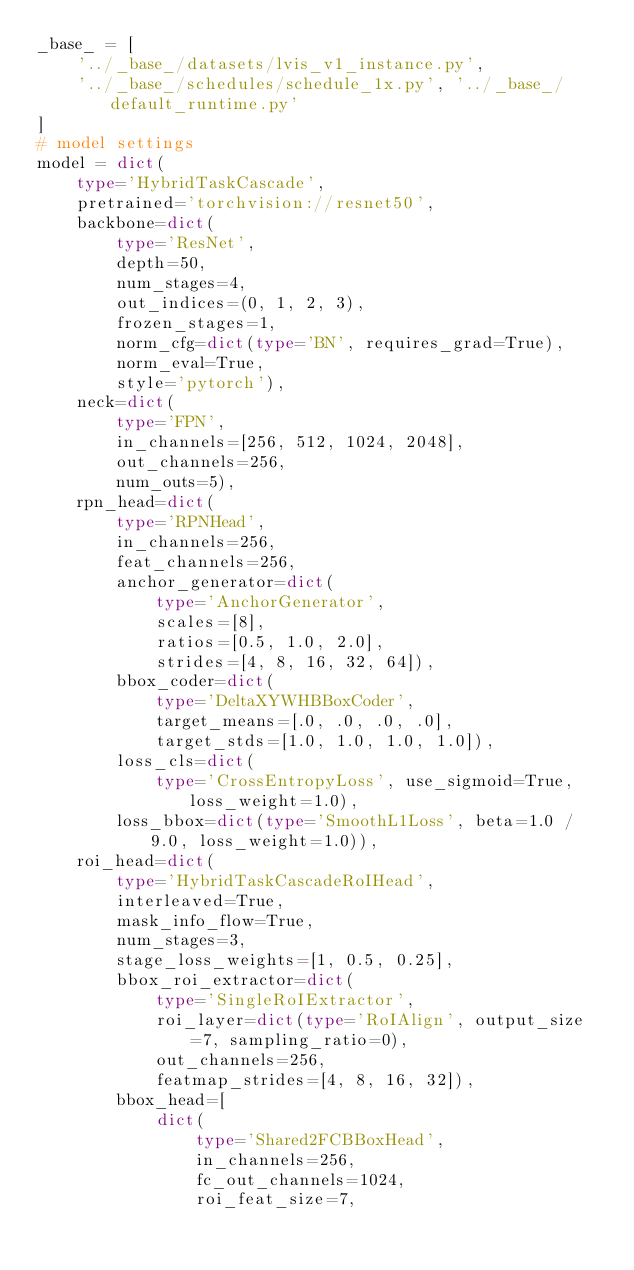Convert code to text. <code><loc_0><loc_0><loc_500><loc_500><_Python_>_base_ = [
    '../_base_/datasets/lvis_v1_instance.py',
    '../_base_/schedules/schedule_1x.py', '../_base_/default_runtime.py'
]
# model settings
model = dict(
    type='HybridTaskCascade',
    pretrained='torchvision://resnet50',
    backbone=dict(
        type='ResNet',
        depth=50,
        num_stages=4,
        out_indices=(0, 1, 2, 3),
        frozen_stages=1,
        norm_cfg=dict(type='BN', requires_grad=True),
        norm_eval=True,
        style='pytorch'),
    neck=dict(
        type='FPN',
        in_channels=[256, 512, 1024, 2048],
        out_channels=256,
        num_outs=5),
    rpn_head=dict(
        type='RPNHead',
        in_channels=256,
        feat_channels=256,
        anchor_generator=dict(
            type='AnchorGenerator',
            scales=[8],
            ratios=[0.5, 1.0, 2.0],
            strides=[4, 8, 16, 32, 64]),
        bbox_coder=dict(
            type='DeltaXYWHBBoxCoder',
            target_means=[.0, .0, .0, .0],
            target_stds=[1.0, 1.0, 1.0, 1.0]),
        loss_cls=dict(
            type='CrossEntropyLoss', use_sigmoid=True, loss_weight=1.0),
        loss_bbox=dict(type='SmoothL1Loss', beta=1.0 / 9.0, loss_weight=1.0)),
    roi_head=dict(
        type='HybridTaskCascadeRoIHead',
        interleaved=True,
        mask_info_flow=True,
        num_stages=3,
        stage_loss_weights=[1, 0.5, 0.25],
        bbox_roi_extractor=dict(
            type='SingleRoIExtractor',
            roi_layer=dict(type='RoIAlign', output_size=7, sampling_ratio=0),
            out_channels=256,
            featmap_strides=[4, 8, 16, 32]),
        bbox_head=[
            dict(
                type='Shared2FCBBoxHead',
                in_channels=256,
                fc_out_channels=1024,
                roi_feat_size=7,</code> 